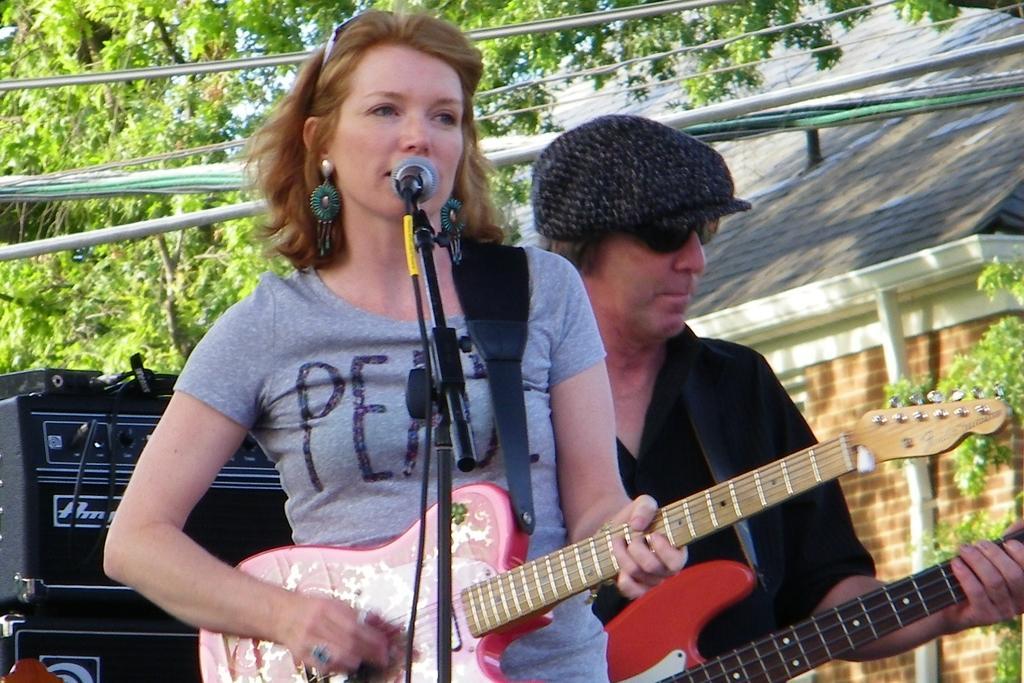Describe this image in one or two sentences. This picture shows a woman Standing and playing guitar and singing with the help of a microphone and we see a man playing guitar on the side and we see couple of trees and house on the side 